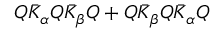<formula> <loc_0><loc_0><loc_500><loc_500>Q \bar { K } _ { \alpha } Q \bar { K } _ { \beta } Q + Q \bar { K } _ { \beta } Q \bar { K } _ { \alpha } Q</formula> 